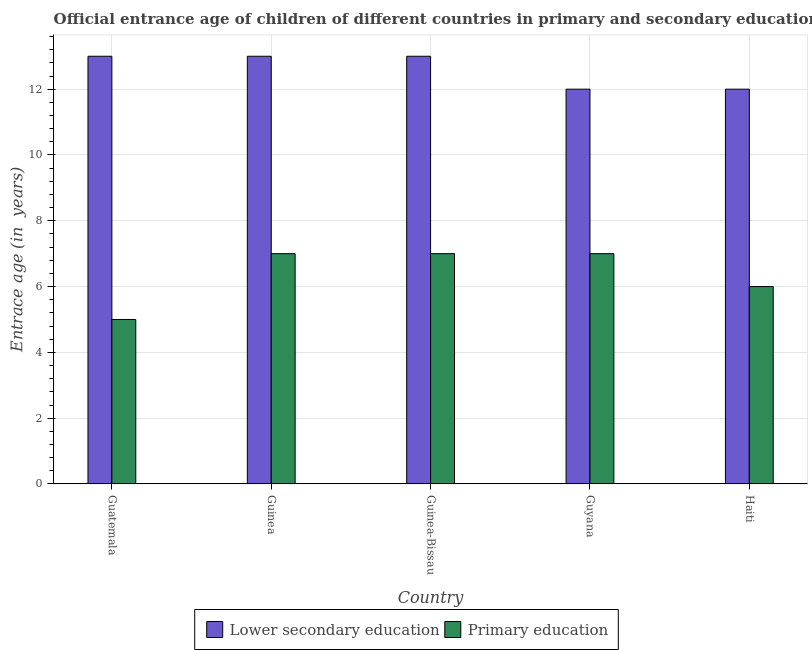How many groups of bars are there?
Provide a succinct answer. 5. Are the number of bars per tick equal to the number of legend labels?
Offer a terse response. Yes. Are the number of bars on each tick of the X-axis equal?
Keep it short and to the point. Yes. How many bars are there on the 5th tick from the left?
Keep it short and to the point. 2. How many bars are there on the 5th tick from the right?
Make the answer very short. 2. What is the label of the 4th group of bars from the left?
Your response must be concise. Guyana. What is the entrance age of children in lower secondary education in Guatemala?
Give a very brief answer. 13. Across all countries, what is the maximum entrance age of children in lower secondary education?
Keep it short and to the point. 13. Across all countries, what is the minimum entrance age of children in lower secondary education?
Your answer should be compact. 12. In which country was the entrance age of children in lower secondary education maximum?
Offer a very short reply. Guatemala. In which country was the entrance age of children in lower secondary education minimum?
Offer a terse response. Guyana. What is the total entrance age of children in lower secondary education in the graph?
Provide a short and direct response. 63. What is the difference between the entrance age of children in lower secondary education in Guinea-Bissau and that in Guyana?
Ensure brevity in your answer.  1. What is the average entrance age of children in lower secondary education per country?
Provide a succinct answer. 12.6. What is the difference between the entrance age of chiildren in primary education and entrance age of children in lower secondary education in Guinea-Bissau?
Your response must be concise. -6. What is the ratio of the entrance age of chiildren in primary education in Guinea to that in Haiti?
Provide a succinct answer. 1.17. What is the difference between the highest and the lowest entrance age of children in lower secondary education?
Provide a succinct answer. 1. Is the sum of the entrance age of chiildren in primary education in Guinea and Guinea-Bissau greater than the maximum entrance age of children in lower secondary education across all countries?
Offer a terse response. Yes. What does the 2nd bar from the left in Guatemala represents?
Provide a short and direct response. Primary education. What does the 2nd bar from the right in Guinea-Bissau represents?
Your response must be concise. Lower secondary education. How many bars are there?
Your answer should be very brief. 10. Are the values on the major ticks of Y-axis written in scientific E-notation?
Keep it short and to the point. No. Does the graph contain any zero values?
Provide a short and direct response. No. Does the graph contain grids?
Provide a succinct answer. Yes. Where does the legend appear in the graph?
Make the answer very short. Bottom center. What is the title of the graph?
Provide a succinct answer. Official entrance age of children of different countries in primary and secondary education. Does "Technicians" appear as one of the legend labels in the graph?
Provide a succinct answer. No. What is the label or title of the X-axis?
Provide a succinct answer. Country. What is the label or title of the Y-axis?
Your answer should be very brief. Entrace age (in  years). What is the Entrace age (in  years) in Lower secondary education in Guatemala?
Make the answer very short. 13. What is the Entrace age (in  years) of Lower secondary education in Guinea?
Provide a short and direct response. 13. What is the Entrace age (in  years) in Primary education in Guinea-Bissau?
Offer a very short reply. 7. What is the Entrace age (in  years) of Lower secondary education in Guyana?
Make the answer very short. 12. What is the Entrace age (in  years) of Primary education in Guyana?
Give a very brief answer. 7. Across all countries, what is the maximum Entrace age (in  years) in Lower secondary education?
Offer a terse response. 13. Across all countries, what is the minimum Entrace age (in  years) in Primary education?
Offer a very short reply. 5. What is the difference between the Entrace age (in  years) of Lower secondary education in Guatemala and that in Guinea?
Your response must be concise. 0. What is the difference between the Entrace age (in  years) in Primary education in Guatemala and that in Guinea?
Ensure brevity in your answer.  -2. What is the difference between the Entrace age (in  years) of Lower secondary education in Guatemala and that in Guinea-Bissau?
Offer a very short reply. 0. What is the difference between the Entrace age (in  years) of Lower secondary education in Guatemala and that in Guyana?
Offer a very short reply. 1. What is the difference between the Entrace age (in  years) in Primary education in Guatemala and that in Haiti?
Make the answer very short. -1. What is the difference between the Entrace age (in  years) of Lower secondary education in Guinea and that in Guyana?
Your answer should be compact. 1. What is the difference between the Entrace age (in  years) of Primary education in Guinea and that in Guyana?
Provide a succinct answer. 0. What is the difference between the Entrace age (in  years) in Lower secondary education in Guinea-Bissau and that in Haiti?
Give a very brief answer. 1. What is the difference between the Entrace age (in  years) of Lower secondary education in Guyana and that in Haiti?
Your answer should be very brief. 0. What is the difference between the Entrace age (in  years) of Lower secondary education in Guatemala and the Entrace age (in  years) of Primary education in Haiti?
Give a very brief answer. 7. What is the difference between the Entrace age (in  years) in Lower secondary education in Guinea and the Entrace age (in  years) in Primary education in Guinea-Bissau?
Make the answer very short. 6. What is the ratio of the Entrace age (in  years) of Lower secondary education in Guatemala to that in Guinea?
Your response must be concise. 1. What is the ratio of the Entrace age (in  years) in Primary education in Guatemala to that in Guinea?
Your answer should be very brief. 0.71. What is the ratio of the Entrace age (in  years) in Lower secondary education in Guatemala to that in Guinea-Bissau?
Ensure brevity in your answer.  1. What is the ratio of the Entrace age (in  years) in Primary education in Guatemala to that in Guinea-Bissau?
Provide a succinct answer. 0.71. What is the ratio of the Entrace age (in  years) of Lower secondary education in Guatemala to that in Guyana?
Offer a terse response. 1.08. What is the ratio of the Entrace age (in  years) in Lower secondary education in Guatemala to that in Haiti?
Give a very brief answer. 1.08. What is the ratio of the Entrace age (in  years) of Lower secondary education in Guinea to that in Guinea-Bissau?
Your response must be concise. 1. What is the ratio of the Entrace age (in  years) of Primary education in Guinea to that in Guinea-Bissau?
Provide a succinct answer. 1. What is the ratio of the Entrace age (in  years) of Lower secondary education in Guinea to that in Guyana?
Your answer should be very brief. 1.08. What is the ratio of the Entrace age (in  years) in Lower secondary education in Guinea to that in Haiti?
Your response must be concise. 1.08. What is the ratio of the Entrace age (in  years) in Lower secondary education in Guinea-Bissau to that in Guyana?
Offer a terse response. 1.08. What is the ratio of the Entrace age (in  years) in Primary education in Guinea-Bissau to that in Guyana?
Your response must be concise. 1. What is the difference between the highest and the second highest Entrace age (in  years) of Lower secondary education?
Keep it short and to the point. 0. What is the difference between the highest and the second highest Entrace age (in  years) in Primary education?
Your response must be concise. 0. What is the difference between the highest and the lowest Entrace age (in  years) in Primary education?
Provide a succinct answer. 2. 